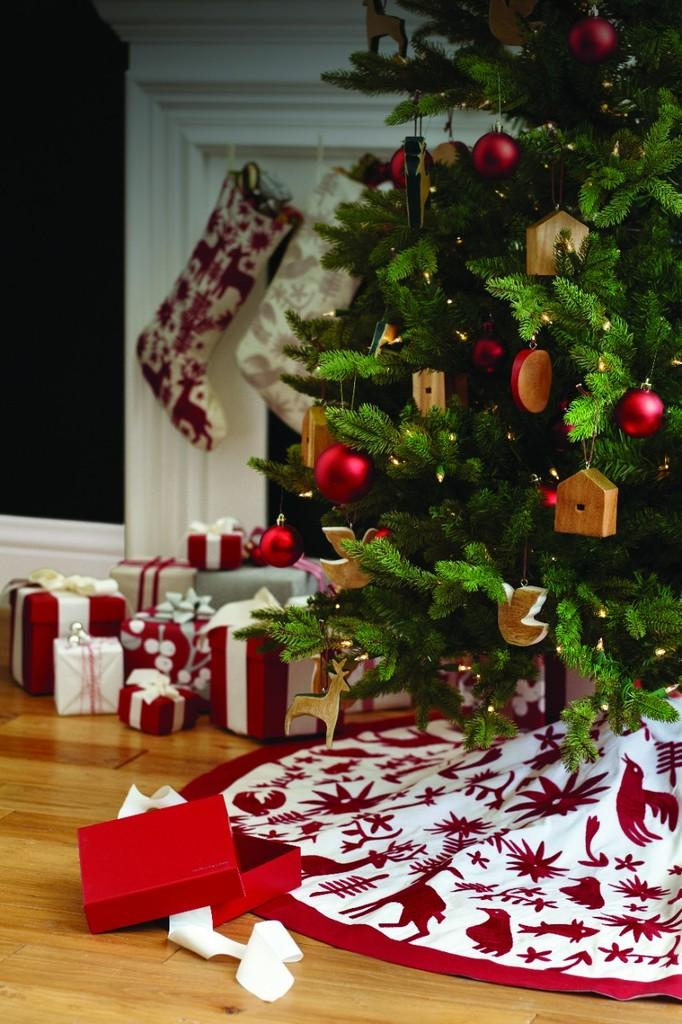What items can be seen in the image that are typically given as presents? There are gifts and toys in the image that are typically given as presents. What type of tree is present in the image? There is a Christmas tree in the image. What type of objects can be seen in the image that are often used for playing? There are toys and balls in the image that are often used for playing. What type of decorations are visible in the image? There are decorations in the image. What type of fabric is present in the image? There is cloth in the image. What type of disposable paper product is visible in the image? There are tissues in the image. What type of clothing item is visible in the image? There are socks in the image. What type of surface is visible in the image? There is a floor visible in the image. What type of art is displayed on the wall in the image? There is no art displayed on the wall in the image. What type of question is being asked in the image? There is no question being asked in the image. What type of statement is being made in the image? There is no statement being made in the image. 